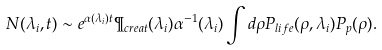<formula> <loc_0><loc_0><loc_500><loc_500>N ( \lambda _ { i } , t ) \sim e ^ { \alpha ( \lambda _ { i } ) t } \P _ { c r e a t } ( \lambda _ { i } ) \alpha ^ { - 1 } ( \lambda _ { i } ) \int d \rho P _ { l i f e } ( \rho , \lambda _ { i } ) P _ { p } ( \rho ) .</formula> 